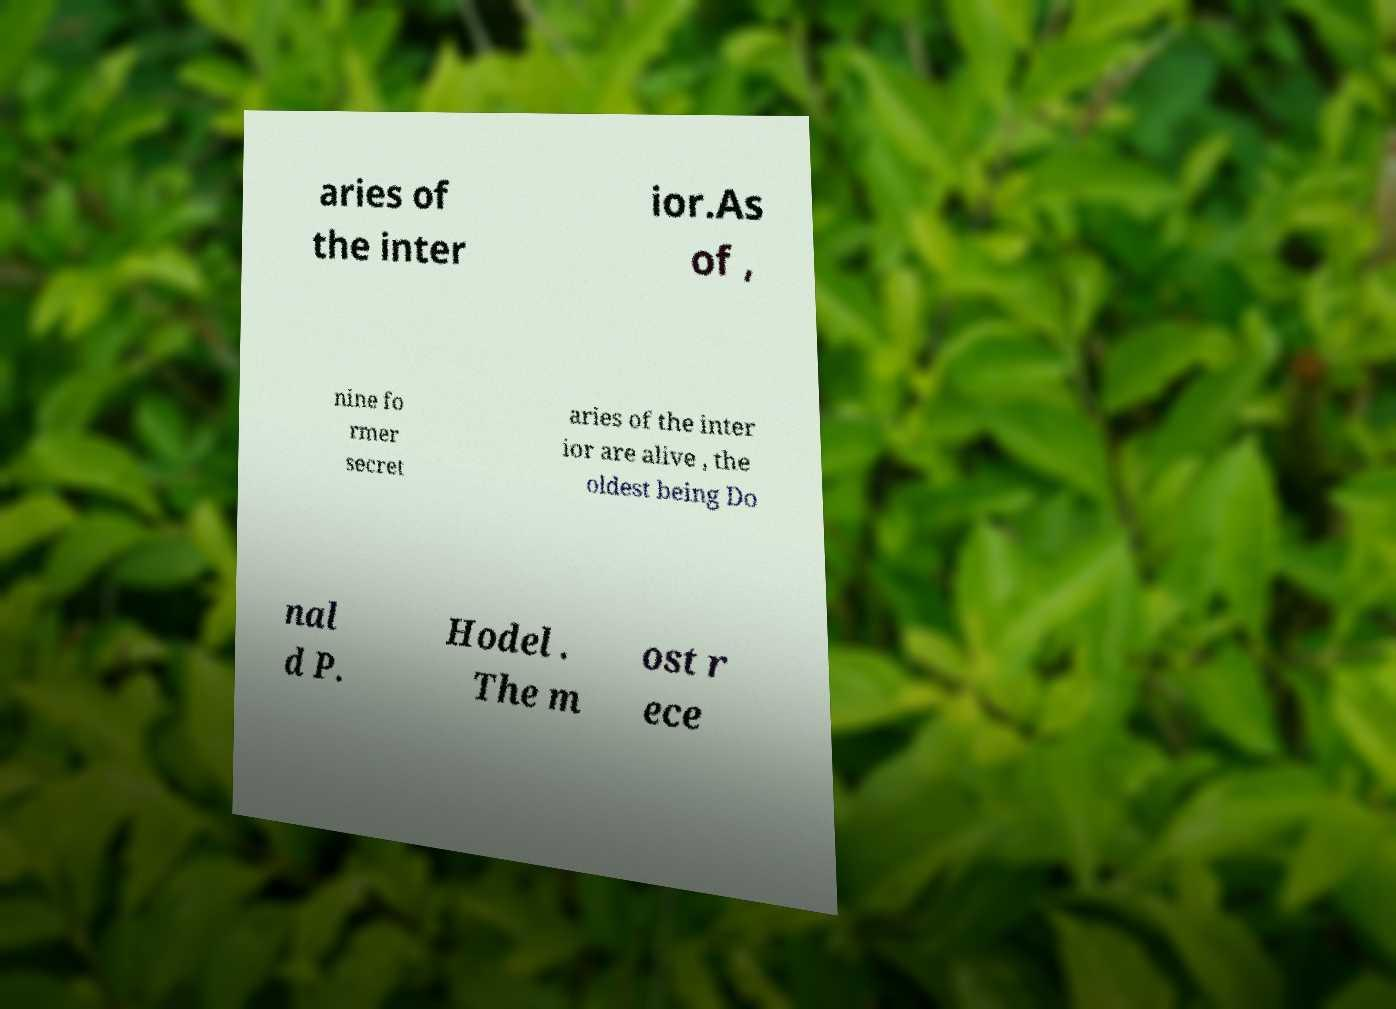What messages or text are displayed in this image? I need them in a readable, typed format. aries of the inter ior.As of , nine fo rmer secret aries of the inter ior are alive , the oldest being Do nal d P. Hodel . The m ost r ece 